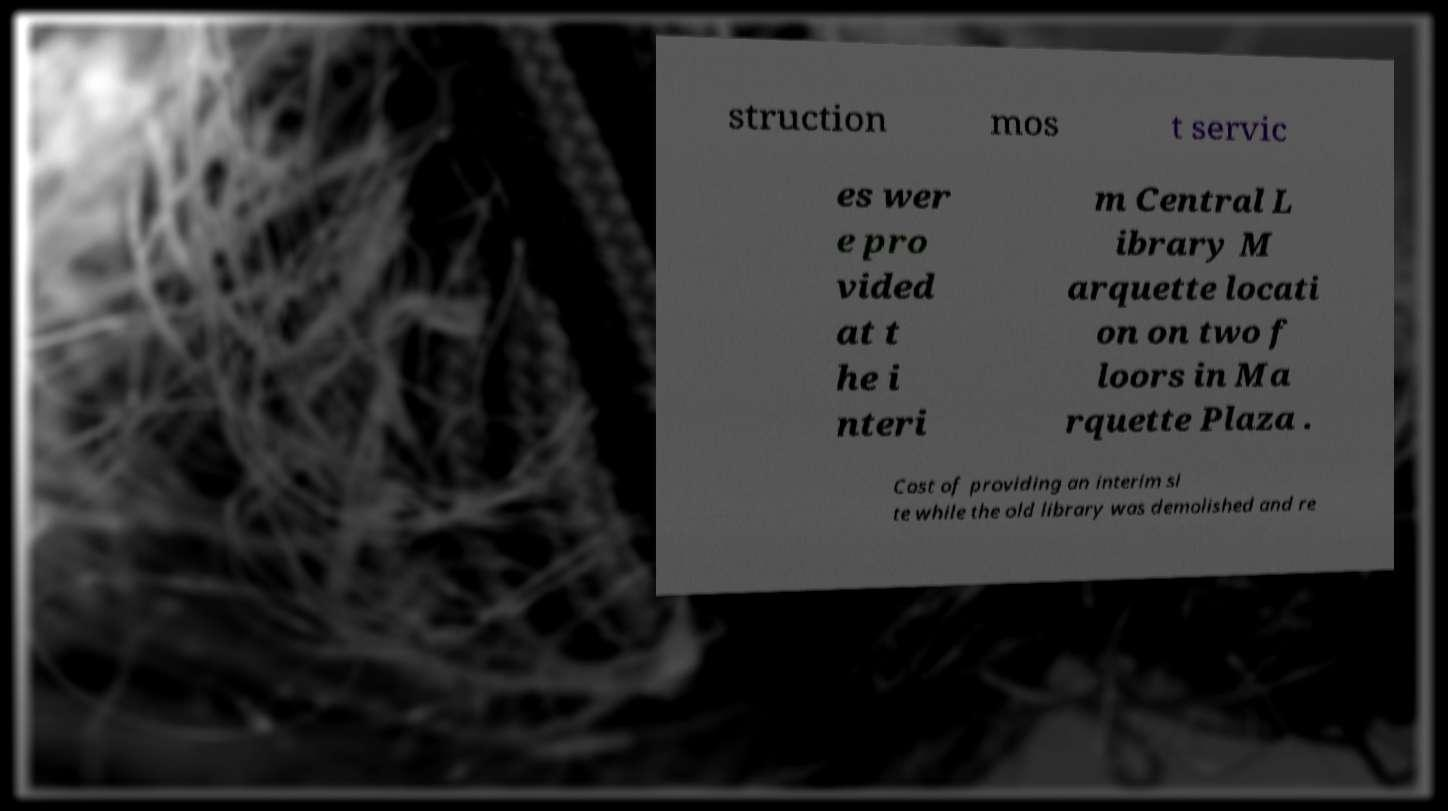I need the written content from this picture converted into text. Can you do that? struction mos t servic es wer e pro vided at t he i nteri m Central L ibrary M arquette locati on on two f loors in Ma rquette Plaza . Cost of providing an interim si te while the old library was demolished and re 